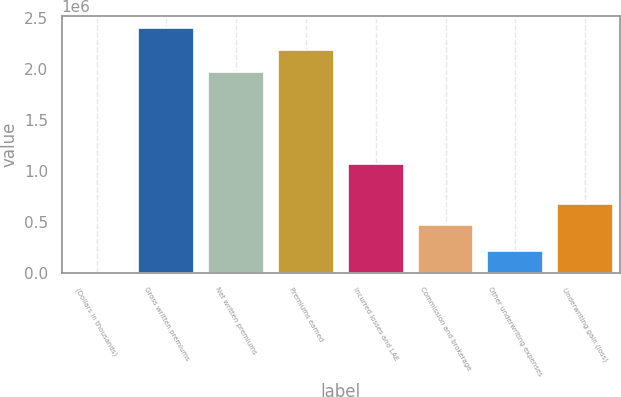Convert chart to OTSL. <chart><loc_0><loc_0><loc_500><loc_500><bar_chart><fcel>(Dollars in thousands)<fcel>Gross written premiums<fcel>Net written premiums<fcel>Premiums earned<fcel>Incurred losses and LAE<fcel>Commission and brokerage<fcel>Other underwriting expenses<fcel>Underwriting gain (loss)<nl><fcel>2016<fcel>2.39533e+06<fcel>1.97058e+06<fcel>2.18295e+06<fcel>1.06848e+06<fcel>465953<fcel>214394<fcel>678331<nl></chart> 